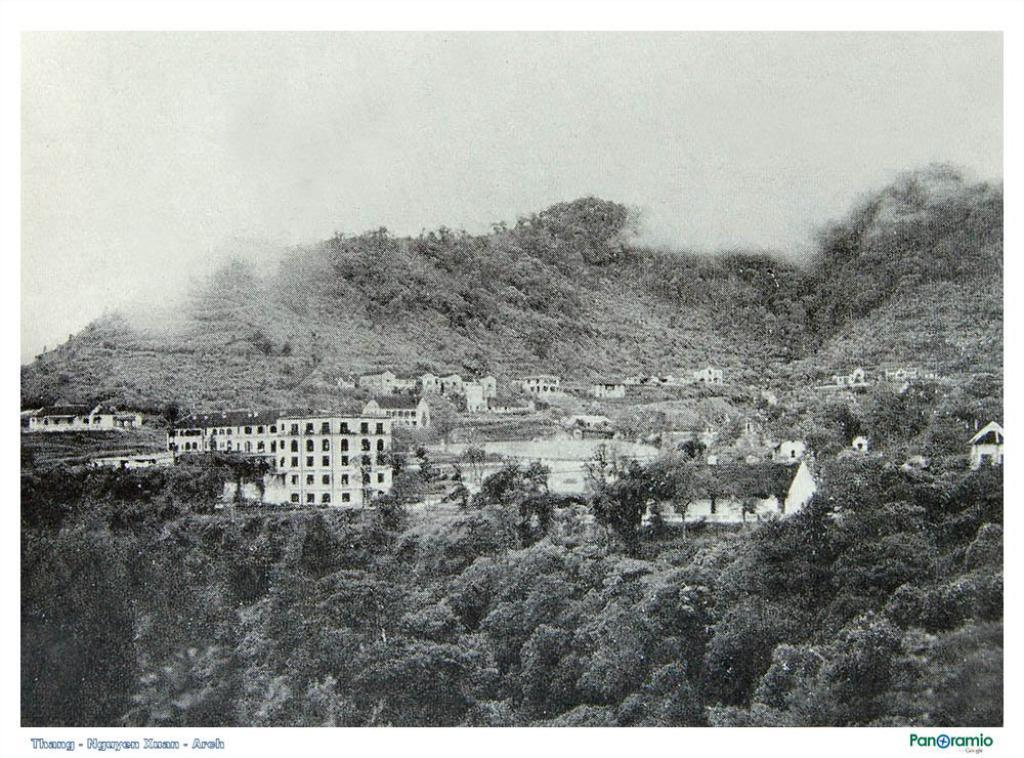What type of picture is in the image? The image contains a black and white picture. What is depicted in the picture? The picture depicts buildings and trees. What else can be seen in the image besides the picture? The sky is visible in the picture, and there is text present in the image. How many snails can be seen crawling on the lake in the image? There is no lake or snails present in the image. What event is about to start in the image? There is no event or indication of a start in the image. 